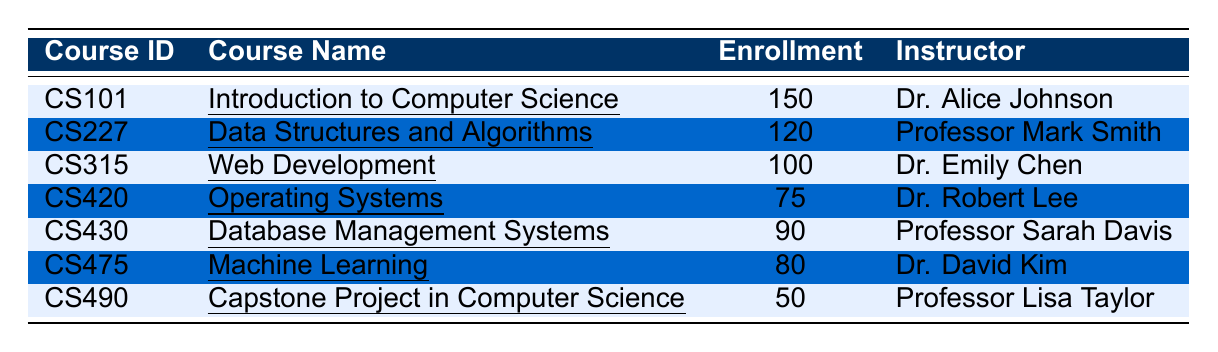What is the enrollment count for the course "Data Structures and Algorithms"? By looking at the row for "Data Structures and Algorithms," the enrollment count is directly stated as 120.
Answer: 120 Which instructor teaches the course "Web Development"? In the row for "Web Development," it lists the instructor as Dr. Emily Chen.
Answer: Dr. Emily Chen How many students are enrolled in the "Capstone Project in Computer Science"? The enrollment count for "Capstone Project in Computer Science" is provided as 50 in its respective row.
Answer: 50 What is the total enrollment count for all courses listed in the table? Adding all the enrollment counts (150 + 120 + 100 + 75 + 90 + 80 + 50) gives 665.
Answer: 665 Is the enrollment count for "Machine Learning" greater than that for "Database Management Systems"? Comparing the two courses, "Machine Learning" has 80 students, while "Database Management Systems" has 90. Since 80 is less than 90, the answer is no.
Answer: No What is the average enrollment across all courses in the table? To find the average, sum the enrollment counts (150 + 120 + 100 + 75 + 90 + 80 + 50 = 665) and divide by the number of courses (7). This results in an average of 665/7 = 95.71, which rounds to 96 when considering only whole students.
Answer: 96 Which course has the highest enrollment count and what is that count? The table indicates that "Introduction to Computer Science" has the highest enrollment at 150 students.
Answer: 150 How many more students are enrolled in "Introduction to Computer Science" than in "Machine Learning"? The enrollment for "Introduction to Computer Science" is 150 and for "Machine Learning" is 80. The difference is 150 - 80 = 70.
Answer: 70 Is there a course with an enrollment count of less than 60? None of the courses listed have an enrollment count lower than 50, therefore the answer is no.
Answer: No How many courses have an enrollment count of 100 or more? The courses with 100 or more enrollments are "Introduction to Computer Science," "Data Structures and Algorithms," and "Web Development." This totals to 3 courses.
Answer: 3 